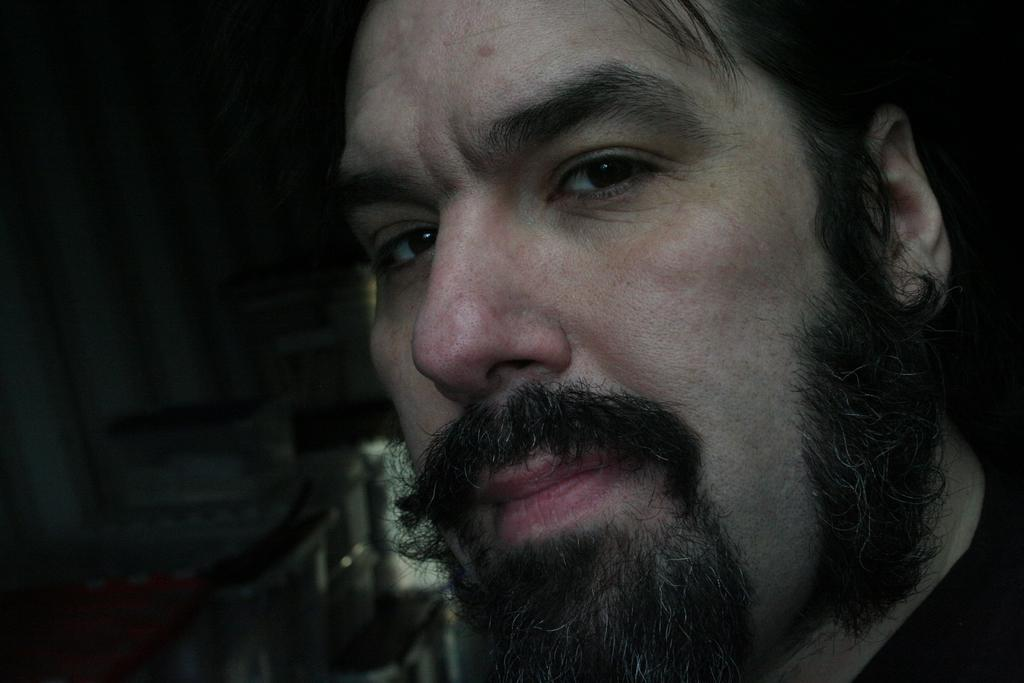What is the main subject of the image? There is a man's face in the image. What colors can be seen in the background of the image? There are objects with white color and objects with black color in the background of the image. How many rings is the man wearing on his fingers in the image? There is no information about rings or fingers in the image; it only shows the man's face. What type of shoes is the man wearing in the image? There is no information about shoes in the image; it only shows the man's face. 